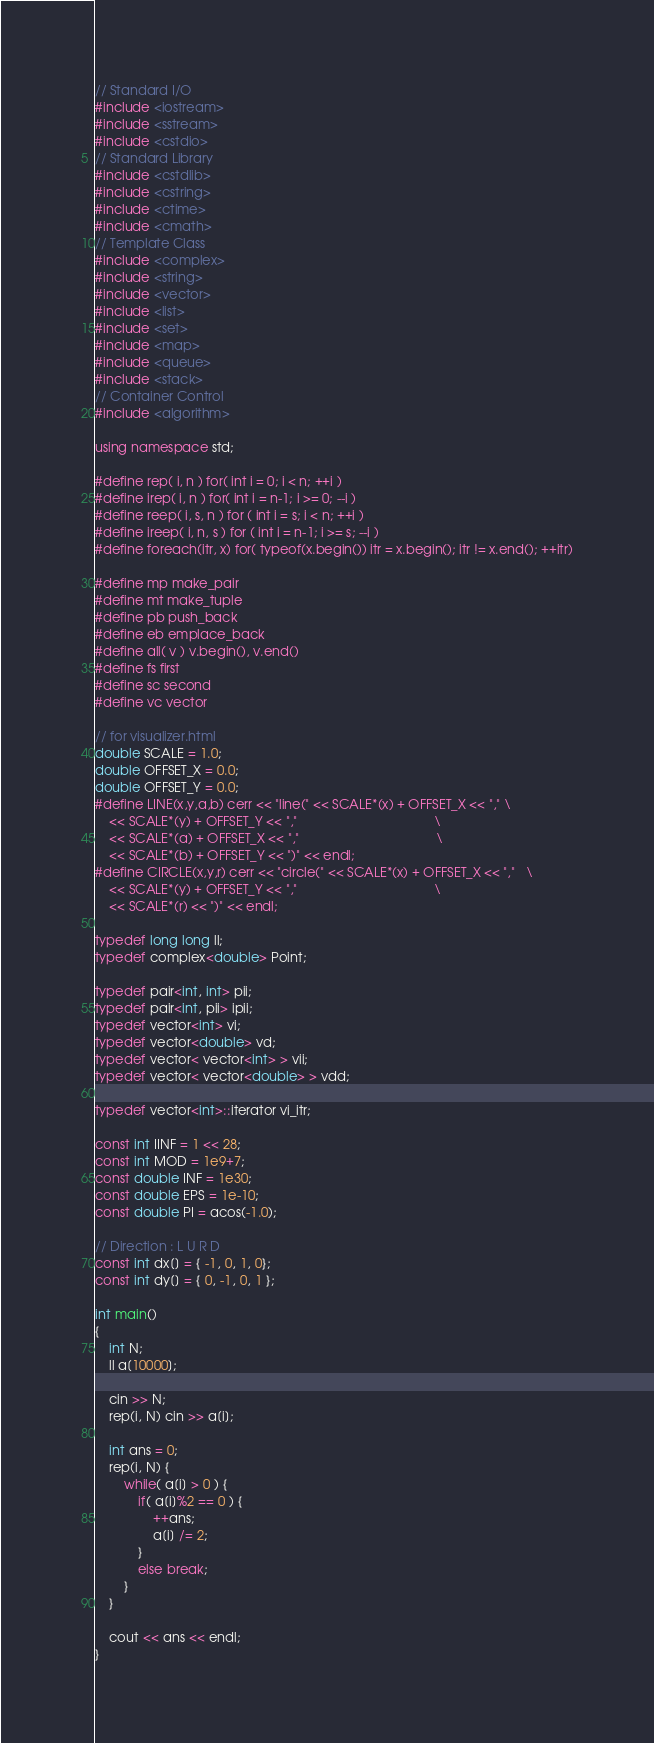<code> <loc_0><loc_0><loc_500><loc_500><_C++_>// Standard I/O
#include <iostream>
#include <sstream>
#include <cstdio>
// Standard Library
#include <cstdlib>
#include <cstring>
#include <ctime>
#include <cmath>
// Template Class
#include <complex>
#include <string>
#include <vector>
#include <list>
#include <set>
#include <map>
#include <queue>
#include <stack>
// Container Control
#include <algorithm>

using namespace std;

#define rep( i, n ) for( int i = 0; i < n; ++i )
#define irep( i, n ) for( int i = n-1; i >= 0; --i )
#define reep( i, s, n ) for ( int i = s; i < n; ++i )
#define ireep( i, n, s ) for ( int i = n-1; i >= s; --i )
#define foreach(itr, x) for( typeof(x.begin()) itr = x.begin(); itr != x.end(); ++itr)

#define mp make_pair
#define mt make_tuple
#define pb push_back
#define eb emplace_back
#define all( v ) v.begin(), v.end()
#define fs first
#define sc second
#define vc vector

// for visualizer.html
double SCALE = 1.0;
double OFFSET_X = 0.0;
double OFFSET_Y = 0.0;
#define LINE(x,y,a,b) cerr << "line(" << SCALE*(x) + OFFSET_X << ","	\
	<< SCALE*(y) + OFFSET_Y << ","										\
	<< SCALE*(a) + OFFSET_X << ","										\
	<< SCALE*(b) + OFFSET_Y << ")" << endl;
#define CIRCLE(x,y,r) cerr << "circle(" << SCALE*(x) + OFFSET_X << ","	\
	<< SCALE*(y) + OFFSET_Y << ","										\
	<< SCALE*(r) << ")" << endl;

typedef long long ll;
typedef complex<double> Point;

typedef pair<int, int> pii;
typedef pair<int, pii> ipii;
typedef vector<int> vi;
typedef vector<double> vd;
typedef vector< vector<int> > vii;
typedef vector< vector<double> > vdd;

typedef vector<int>::iterator vi_itr;

const int IINF = 1 << 28;
const int MOD = 1e9+7;
const double INF = 1e30;
const double EPS = 1e-10;
const double PI = acos(-1.0);

// Direction : L U R D
const int dx[] = { -1, 0, 1, 0};
const int dy[] = { 0, -1, 0, 1 };

int main()
{
    int N;
    ll a[10000];
    
    cin >> N;
    rep(i, N) cin >> a[i];

    int ans = 0;
    rep(i, N) {
        while( a[i] > 0 ) {
            if( a[i]%2 == 0 ) {
                ++ans;
                a[i] /= 2;
            }
            else break;
        }
    }

    cout << ans << endl;
}
</code> 